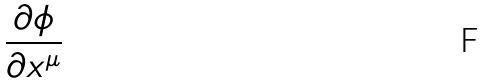Convert formula to latex. <formula><loc_0><loc_0><loc_500><loc_500>\frac { \partial \phi } { \partial x ^ { \mu } }</formula> 